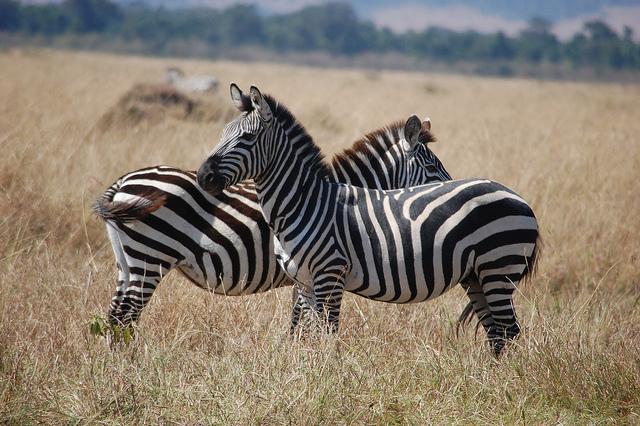Are both zebras facing the same direction?
Quick response, please. No. Are these zebras fighting?
Concise answer only. No. Are there any zebras facing the camera?
Give a very brief answer. No. What is the back zebra swishing?
Write a very short answer. Tail. What is the color of the grass?
Write a very short answer. Brown. What is the majority color of the grass?
Answer briefly. Brown. Are this young zebras?
Give a very brief answer. Yes. How many animals are in this scene?
Short answer required. 2. Are the zebras sleeping?
Write a very short answer. No. Are there bushes or trees?
Concise answer only. Yes. 